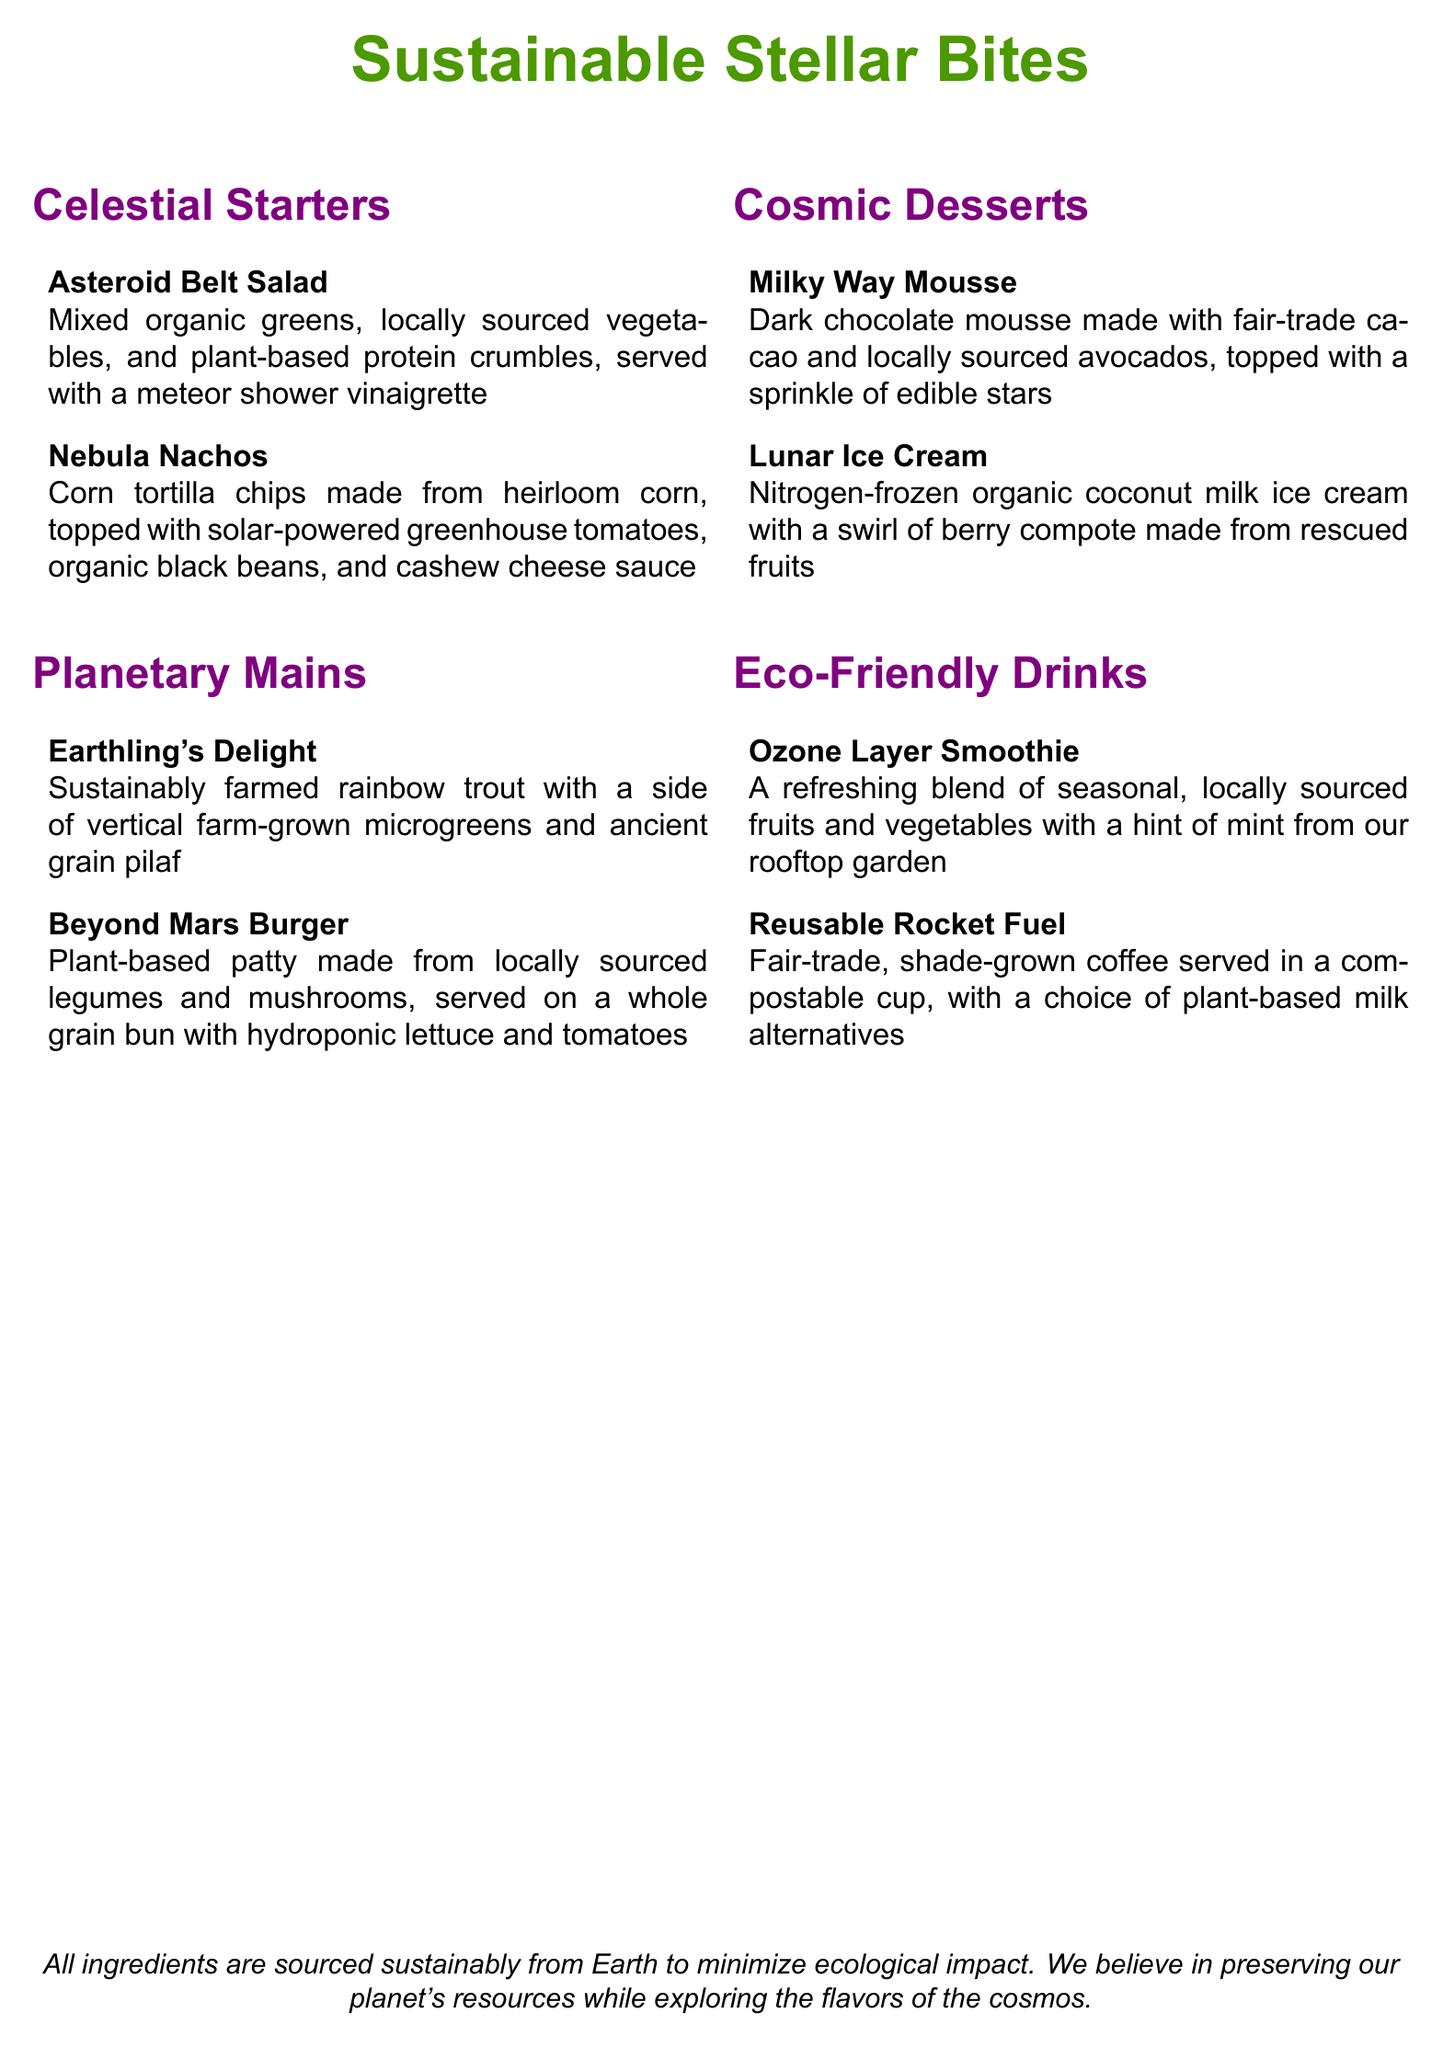What is the name of the first appetizer? The first appetizer listed is "Asteroid Belt Salad."
Answer: Asteroid Belt Salad What type of fish is served in the "Earthling's Delight"? The dish features sustainably farmed rainbow trout.
Answer: rainbow trout What is the main ingredient in the "Beyond Mars Burger"? The main ingredient is a plant-based patty made from locally sourced legumes and mushrooms.
Answer: plant-based patty What kind of ice cream is featured in the dessert section? The dessert section includes "Nitrogen-frozen organic coconut milk ice cream."
Answer: Nitrogen-frozen organic coconut milk ice cream What type of coffee is served under eco-friendly drinks? The menu specifies fair-trade, shade-grown coffee.
Answer: fair-trade, shade-grown coffee How many sections are in the menu? There are four sections in the menu: Celestial Starters, Planetary Mains, Cosmic Desserts, and Eco-Friendly Drinks.
Answer: four What common theme is the menu based on? The menu emphasizes sustainable and eco-friendly food.
Answer: sustainable and eco-friendly food What is the unique ingredient used in "Milky Way Mousse"? The mousse includes dark chocolate made with fair-trade cacao.
Answer: fair-trade cacao What type of tomatoes are used in the "Nebula Nachos"? The recipe calls for solar-powered greenhouse tomatoes.
Answer: solar-powered greenhouse tomatoes 